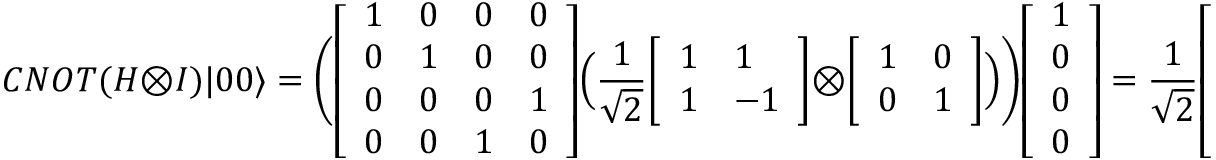<formula> <loc_0><loc_0><loc_500><loc_500>C N O T ( H \otimes I ) | 0 0 \rangle = { \left ( } { \left [ \begin{array} { l l l l } { 1 } & { 0 } & { 0 } & { 0 } \\ { 0 } & { 1 } & { 0 } & { 0 } \\ { 0 } & { 0 } & { 0 } & { 1 } \\ { 0 } & { 0 } & { 1 } & { 0 } \end{array} \right ] } { \left ( } { \frac { 1 } { \sqrt { 2 } } } { \left [ \begin{array} { l l } { 1 } & { 1 } \\ { 1 } & { - 1 } \end{array} \right ] } \otimes { \left [ \begin{array} { l l } { 1 } & { 0 } \\ { 0 } & { 1 } \end{array} \right ] } { \right ) } { \right ) } { \left [ \begin{array} { l } { 1 } \\ { 0 } \\ { 0 } \\ { 0 } \end{array} \right ] } = { \frac { 1 } { \sqrt { 2 } } } { \left [ \begin{array} { l } { 1 } \\ { 0 } \\ { 0 } \\ { 1 } \end{array} \right ] } = { \frac { | 0 0 \rangle + | 1 1 \rangle } { \sqrt { 2 } } }</formula> 